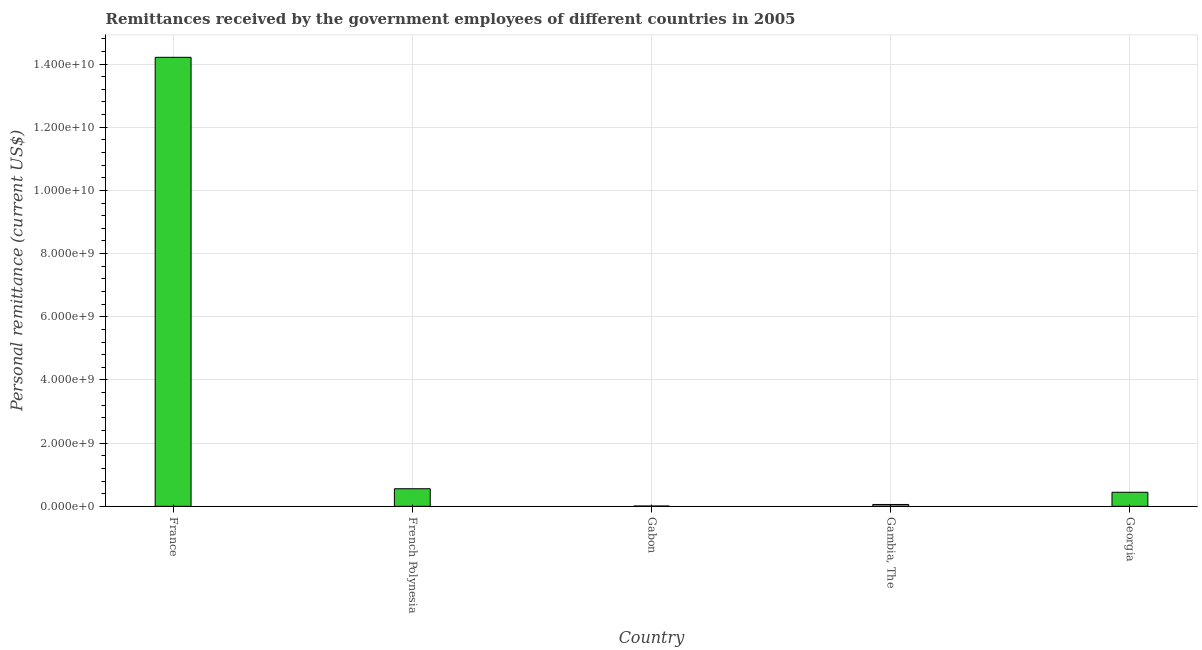Does the graph contain any zero values?
Keep it short and to the point. No. Does the graph contain grids?
Your response must be concise. Yes. What is the title of the graph?
Your answer should be compact. Remittances received by the government employees of different countries in 2005. What is the label or title of the X-axis?
Offer a terse response. Country. What is the label or title of the Y-axis?
Offer a very short reply. Personal remittance (current US$). What is the personal remittances in French Polynesia?
Your answer should be compact. 5.57e+08. Across all countries, what is the maximum personal remittances?
Your response must be concise. 1.42e+1. Across all countries, what is the minimum personal remittances?
Your response must be concise. 1.10e+07. In which country was the personal remittances minimum?
Offer a very short reply. Gabon. What is the sum of the personal remittances?
Provide a succinct answer. 1.53e+1. What is the difference between the personal remittances in France and Gabon?
Make the answer very short. 1.42e+1. What is the average personal remittances per country?
Keep it short and to the point. 3.06e+09. What is the median personal remittances?
Ensure brevity in your answer.  4.46e+08. What is the ratio of the personal remittances in French Polynesia to that in Gabon?
Your answer should be compact. 50.53. Is the personal remittances in French Polynesia less than that in Gabon?
Ensure brevity in your answer.  No. What is the difference between the highest and the second highest personal remittances?
Your response must be concise. 1.37e+1. Is the sum of the personal remittances in French Polynesia and Gabon greater than the maximum personal remittances across all countries?
Offer a terse response. No. What is the difference between the highest and the lowest personal remittances?
Your answer should be very brief. 1.42e+1. In how many countries, is the personal remittances greater than the average personal remittances taken over all countries?
Keep it short and to the point. 1. How many bars are there?
Keep it short and to the point. 5. How many countries are there in the graph?
Keep it short and to the point. 5. What is the Personal remittance (current US$) of France?
Ensure brevity in your answer.  1.42e+1. What is the Personal remittance (current US$) of French Polynesia?
Your answer should be compact. 5.57e+08. What is the Personal remittance (current US$) in Gabon?
Offer a terse response. 1.10e+07. What is the Personal remittance (current US$) in Gambia, The?
Ensure brevity in your answer.  5.93e+07. What is the Personal remittance (current US$) of Georgia?
Make the answer very short. 4.46e+08. What is the difference between the Personal remittance (current US$) in France and French Polynesia?
Give a very brief answer. 1.37e+1. What is the difference between the Personal remittance (current US$) in France and Gabon?
Your answer should be very brief. 1.42e+1. What is the difference between the Personal remittance (current US$) in France and Gambia, The?
Your answer should be very brief. 1.42e+1. What is the difference between the Personal remittance (current US$) in France and Georgia?
Give a very brief answer. 1.38e+1. What is the difference between the Personal remittance (current US$) in French Polynesia and Gabon?
Your answer should be compact. 5.46e+08. What is the difference between the Personal remittance (current US$) in French Polynesia and Gambia, The?
Keep it short and to the point. 4.98e+08. What is the difference between the Personal remittance (current US$) in French Polynesia and Georgia?
Give a very brief answer. 1.11e+08. What is the difference between the Personal remittance (current US$) in Gabon and Gambia, The?
Offer a very short reply. -4.83e+07. What is the difference between the Personal remittance (current US$) in Gabon and Georgia?
Provide a succinct answer. -4.35e+08. What is the difference between the Personal remittance (current US$) in Gambia, The and Georgia?
Your answer should be very brief. -3.87e+08. What is the ratio of the Personal remittance (current US$) in France to that in French Polynesia?
Provide a succinct answer. 25.5. What is the ratio of the Personal remittance (current US$) in France to that in Gabon?
Offer a very short reply. 1288.72. What is the ratio of the Personal remittance (current US$) in France to that in Gambia, The?
Your answer should be compact. 239.65. What is the ratio of the Personal remittance (current US$) in France to that in Georgia?
Offer a terse response. 31.87. What is the ratio of the Personal remittance (current US$) in French Polynesia to that in Gabon?
Keep it short and to the point. 50.53. What is the ratio of the Personal remittance (current US$) in French Polynesia to that in Gambia, The?
Your answer should be compact. 9.4. What is the ratio of the Personal remittance (current US$) in French Polynesia to that in Georgia?
Offer a terse response. 1.25. What is the ratio of the Personal remittance (current US$) in Gabon to that in Gambia, The?
Ensure brevity in your answer.  0.19. What is the ratio of the Personal remittance (current US$) in Gabon to that in Georgia?
Keep it short and to the point. 0.03. What is the ratio of the Personal remittance (current US$) in Gambia, The to that in Georgia?
Offer a very short reply. 0.13. 